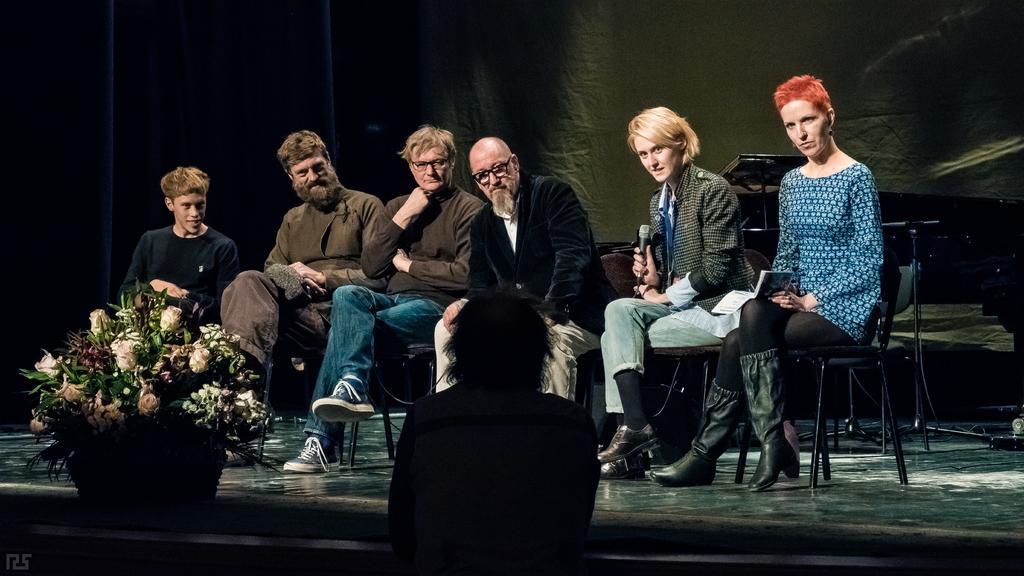How would you summarize this image in a sentence or two? In this image I can see few people are sitting on the chairs. And these people are wearing the different color dresses. In- front of these people I can see the bouquet. To the side I can see another person standing. In the back there is a curtain. 